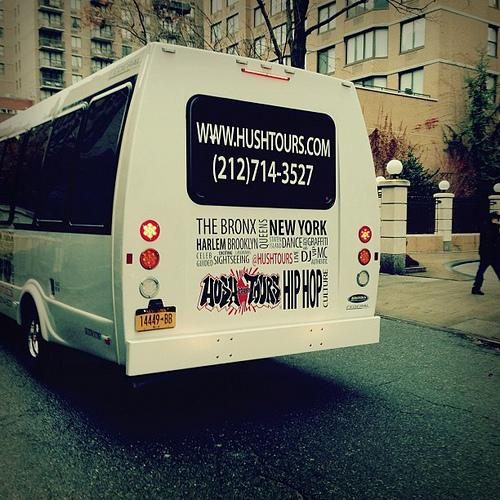Tell me the color and primary action of the person mentioned in the image. The person is walking on a gray cement sidewalk. Briefly describe the bus displayed in the image. A white mini bus with large windows, rear break light, yellow license plate, and an advertisement in black on the back. What kind of interaction is occurring between the fence and the wall? There is an edge of a wall near the part of the fence, creating a border-like interaction. Can you count how many taillights are on the back of the bus? There are three round taillights on the back of the bus. Explain one aspect of the bus's appearance in relation to the street it is on. The bus is on a black asphalt street, with one wheel visible and an edge of the road nearby. Describe the features of the person walking in the image. The person walking on the sidewalk is wearing a hat and appears to be a man. How is the fence depicted in the image? There is a bulb on the fence and a part of it slightly visible. Can you provide details about a building shown in the image? It is a large tan apartment building with balconies, light globes, and a tall green tree in front of it. What kind of tree is present in the image and where is it located? A tall green pine tree is next to a large tan building. What type of light fixtures are present on the building and where are they located? The building has globe lights adjacent to it, and a white glob light on top of a cement post. Describe the main object in the image. A white bus with large windows. How many wheels are visible on the bus? 1 Is there any light orb found in the image? If yes, on what object is it placed? Yes, a white globe light is placed on top of a cement post. What is the color of the license plate on the bus? Yellow Identify an object related to the pedestrian in the image. A man wearing a hat Choose the correct object from the following options: (a) green glob light, (b) yellow glob light, (c) white glob light, (d) blue glob light (c) white glob light What type of vehicle is shown in the image? Minibus Can you spot a pink flower pot on one of the balconies of the tan building? It's quite eye-catching. This instruction is misleading because there is no graffiti artist or mural mentioned in the list of objects. It falsely raises the user's expectation to find an ongoing action involving an artist in the scene, which is not present. Describe the road in the image. Black asphalt street Determine the location of an open umbrella that a person walking is holding. The umbrella has a colorful pattern. No, it's not mentioned in the image. What color is the building near the bus? Tan Is there a column with a light on top of it in the image? What does it look like? Yes, it is a cement post with a white globe light on top of it. What type of tree is next to the large tan building? Tall pine tree What color are the brake lights on the bus? Red Can you find a blue bicycle parked near the bus? There should be one close to the sidewalk. There is no mention of any blue bicycle in the list of objects in the image. This instruction is misleading because it includes a nonexistent object in the image, asking the user to look for something that isn't there. Which object is located directly under the red taillight on the bus? Round white light Is there a person walking in the scene? If so, where are they walking? Yes, they are walking on the sidewalk. Identify one distinguishing feature of the windows on the bus. Tinted windows Describe the advertisement on the bus. Advertisement in black on the back of a bus Provide a short description of the surroundings in the image. The bus is on the street, near a building with balconies, a tall green tree, and a person walking on the sidewalk. Select the correct description for the object next to the rear brake light on the bus. Options: (a) red and white sign, (b) yellow and black tag, (c) gray and white label, (d) blue and white sticker. (b) yellow and black tag Mention one object found on the back of the bus. Rear brake light What type of tree is found in the image? Tall green pine tree 